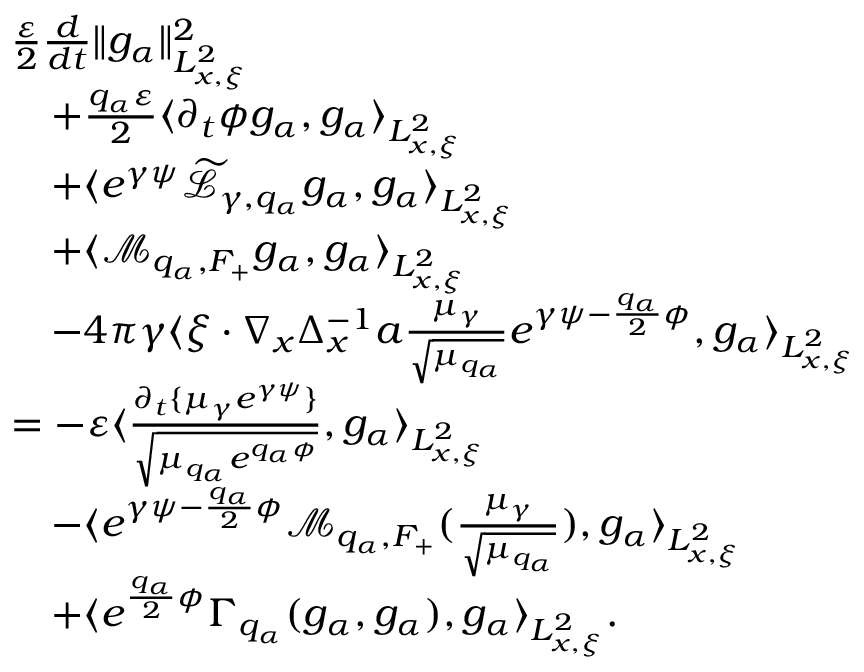<formula> <loc_0><loc_0><loc_500><loc_500>\begin{array} { r l } & { \frac { \varepsilon } { 2 } \frac { d } { d t } \| g _ { \alpha } \| _ { L _ { x , \xi } ^ { 2 } } ^ { 2 } } \\ & { \quad + \frac { q _ { \alpha } \varepsilon } { 2 } \langle \partial _ { t } \phi g _ { \alpha } , g _ { \alpha } \rangle _ { L _ { x , \xi } ^ { 2 } } } \\ & { \quad + \langle e ^ { \gamma \psi } \widetilde { \mathcal { L } } _ { \gamma , q _ { \alpha } } g _ { \alpha } , g _ { \alpha } \rangle _ { L _ { x , \xi } ^ { 2 } } } \\ & { \quad + \langle \mathcal { M } _ { q _ { \alpha } , F _ { + } } g _ { \alpha } , g _ { \alpha } \rangle _ { L _ { x , \xi } ^ { 2 } } } \\ & { \quad - 4 \pi \gamma \langle \xi \cdot \nabla _ { x } \Delta _ { x } ^ { - 1 } a \frac { \mu _ { \gamma } } { \sqrt { \mu _ { q _ { \alpha } } } } e ^ { \gamma \psi - \frac { q _ { \alpha } } { 2 } \phi } , g _ { \alpha } \rangle _ { L _ { x , \xi } ^ { 2 } } } \\ & { = - \varepsilon \langle \frac { \partial _ { t } \{ \mu _ { \gamma } e ^ { \gamma \psi } \} } { \sqrt { \mu _ { q _ { \alpha } } e ^ { q _ { \alpha } \phi } } } , g _ { \alpha } \rangle _ { L _ { x , \xi } ^ { 2 } } } \\ & { \quad - \langle e ^ { \gamma \psi - \frac { q _ { \alpha } } { 2 } \phi } \mathcal { M } _ { q _ { \alpha } , F _ { + } } ( \frac { \mu _ { \gamma } } { \sqrt { \mu _ { q _ { \alpha } } } } ) , g _ { \alpha } \rangle _ { L _ { x , \xi } ^ { 2 } } } \\ & { \quad + \langle e ^ { \frac { q _ { \alpha } } { 2 } \phi } \Gamma _ { q _ { \alpha } } ( g _ { \alpha } , g _ { \alpha } ) , g _ { \alpha } \rangle _ { L _ { x , \xi } ^ { 2 } } . } \end{array}</formula> 